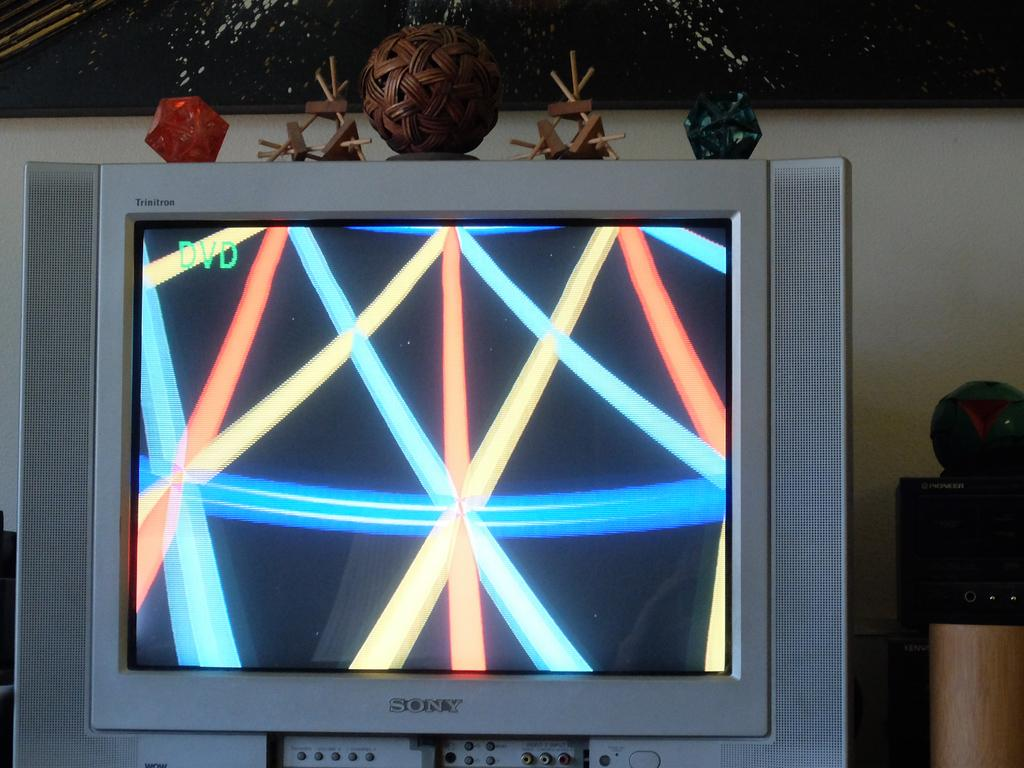<image>
Share a concise interpretation of the image provided. Sony Television that is in DVD mode with different lines. 